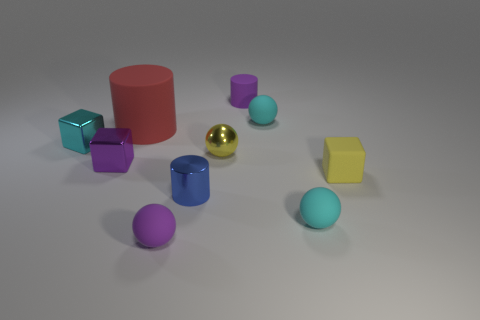Subtract all red balls. Subtract all green cylinders. How many balls are left? 4 Subtract all balls. How many objects are left? 6 Add 7 large red shiny blocks. How many large red shiny blocks exist? 7 Subtract 0 cyan cylinders. How many objects are left? 10 Subtract all small blue cylinders. Subtract all yellow blocks. How many objects are left? 8 Add 5 yellow metallic balls. How many yellow metallic balls are left? 6 